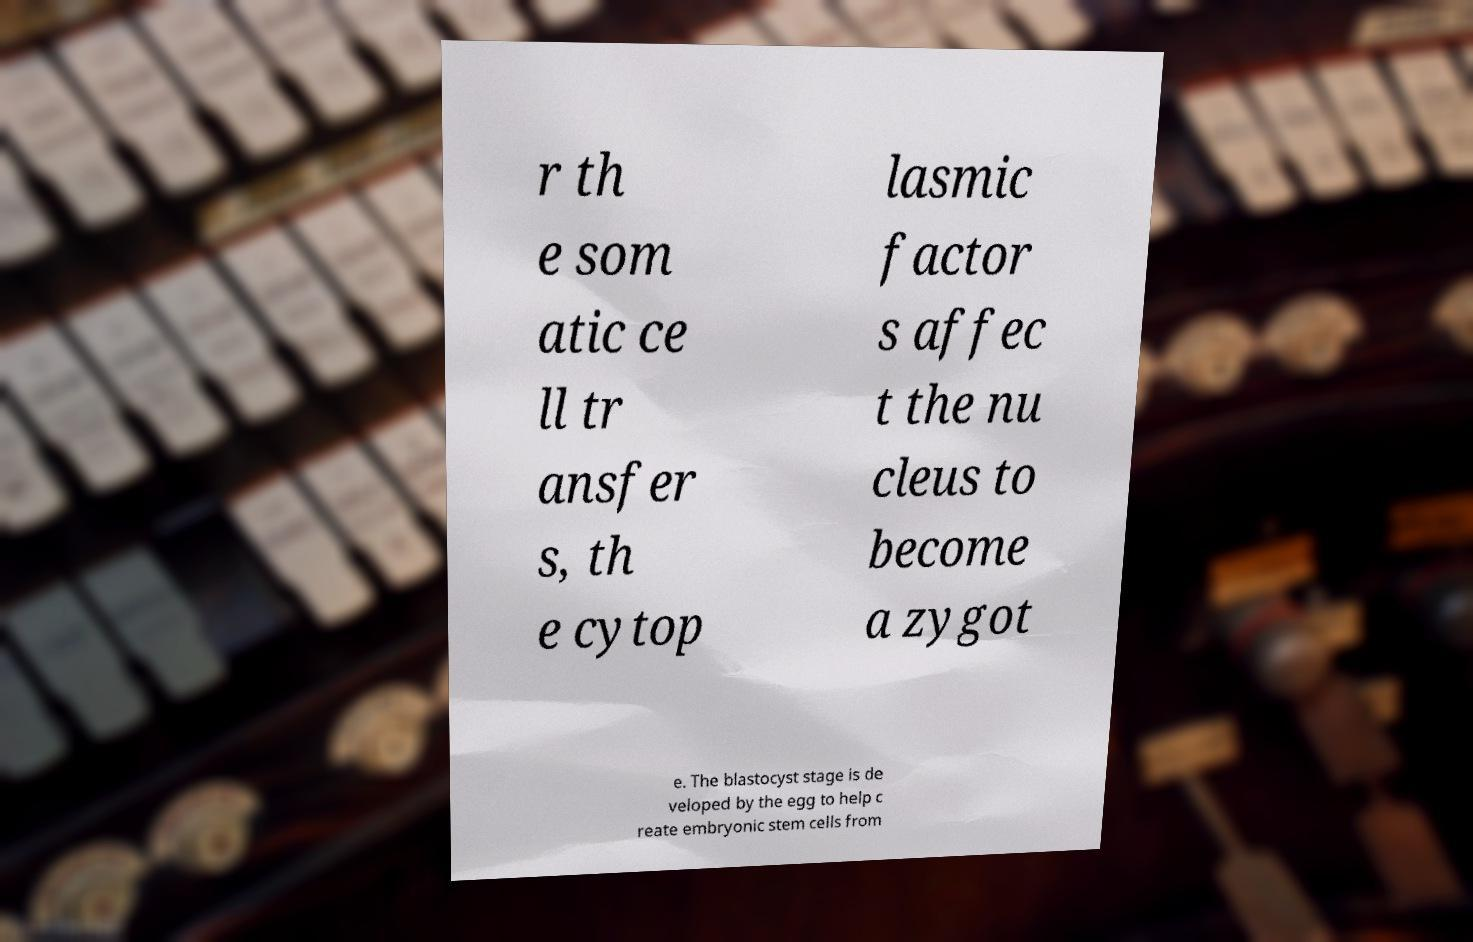Can you read and provide the text displayed in the image?This photo seems to have some interesting text. Can you extract and type it out for me? r th e som atic ce ll tr ansfer s, th e cytop lasmic factor s affec t the nu cleus to become a zygot e. The blastocyst stage is de veloped by the egg to help c reate embryonic stem cells from 